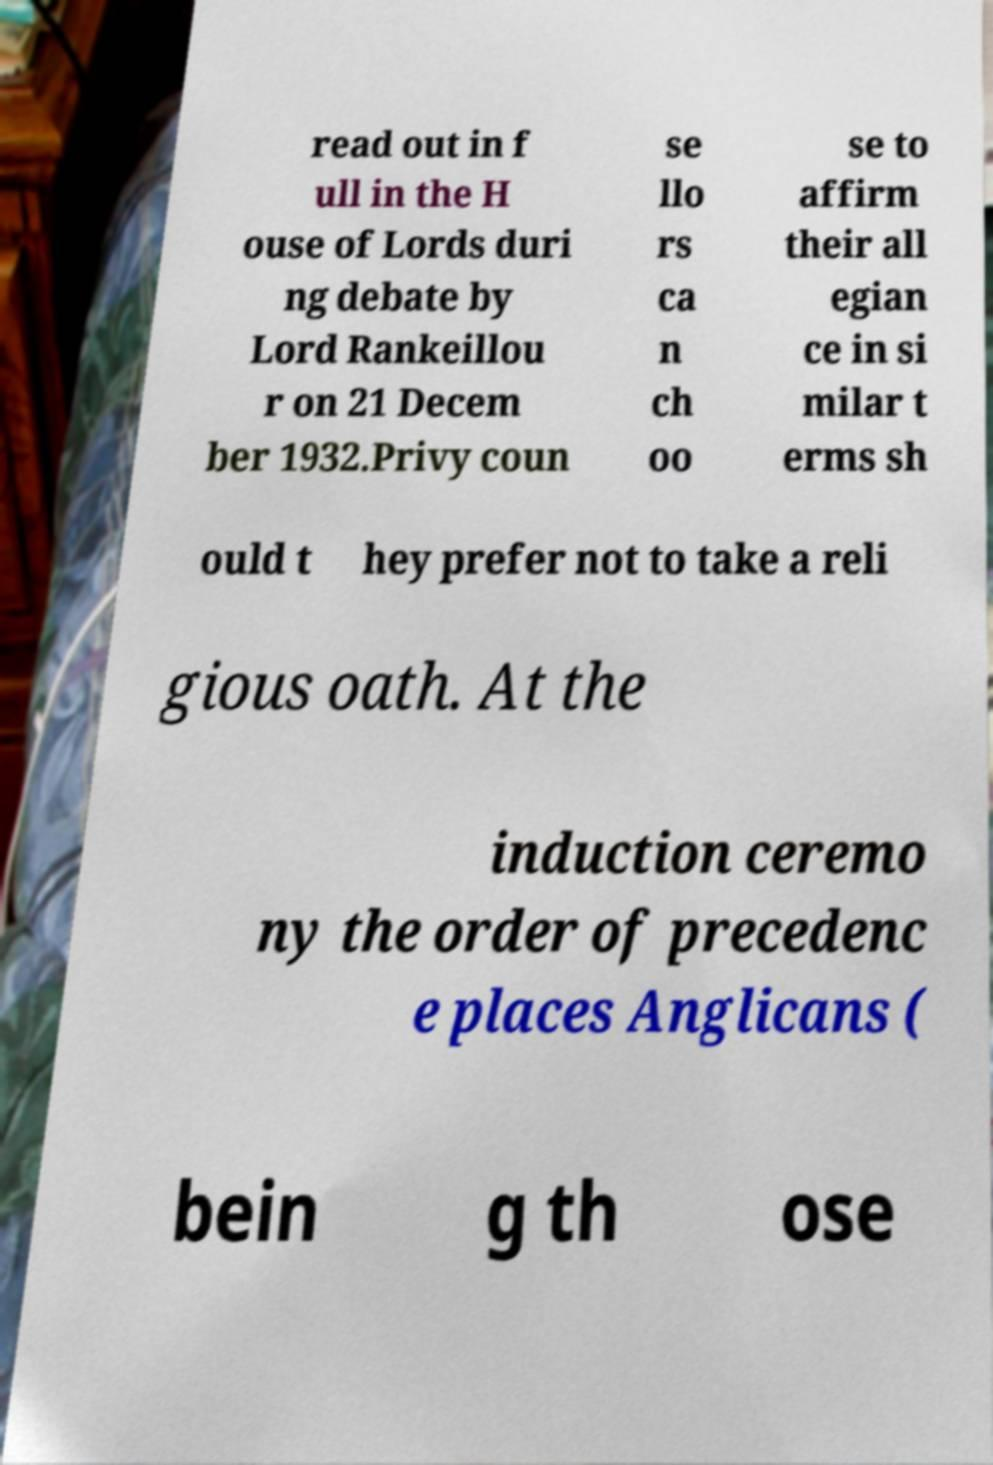There's text embedded in this image that I need extracted. Can you transcribe it verbatim? read out in f ull in the H ouse of Lords duri ng debate by Lord Rankeillou r on 21 Decem ber 1932.Privy coun se llo rs ca n ch oo se to affirm their all egian ce in si milar t erms sh ould t hey prefer not to take a reli gious oath. At the induction ceremo ny the order of precedenc e places Anglicans ( bein g th ose 